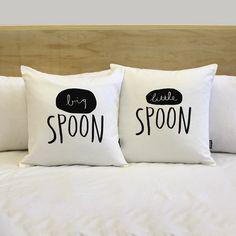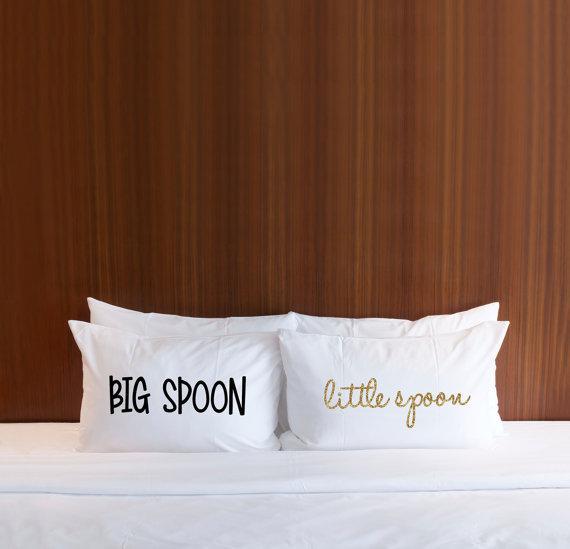The first image is the image on the left, the second image is the image on the right. Considering the images on both sides, is "One image features a pillow design with a spoon pictured as well as black text, and the other image shows two rectangular white pillows with black text." valid? Answer yes or no. No. The first image is the image on the left, the second image is the image on the right. Examine the images to the left and right. Is the description "The right image contains exactly two pillows." accurate? Answer yes or no. No. 